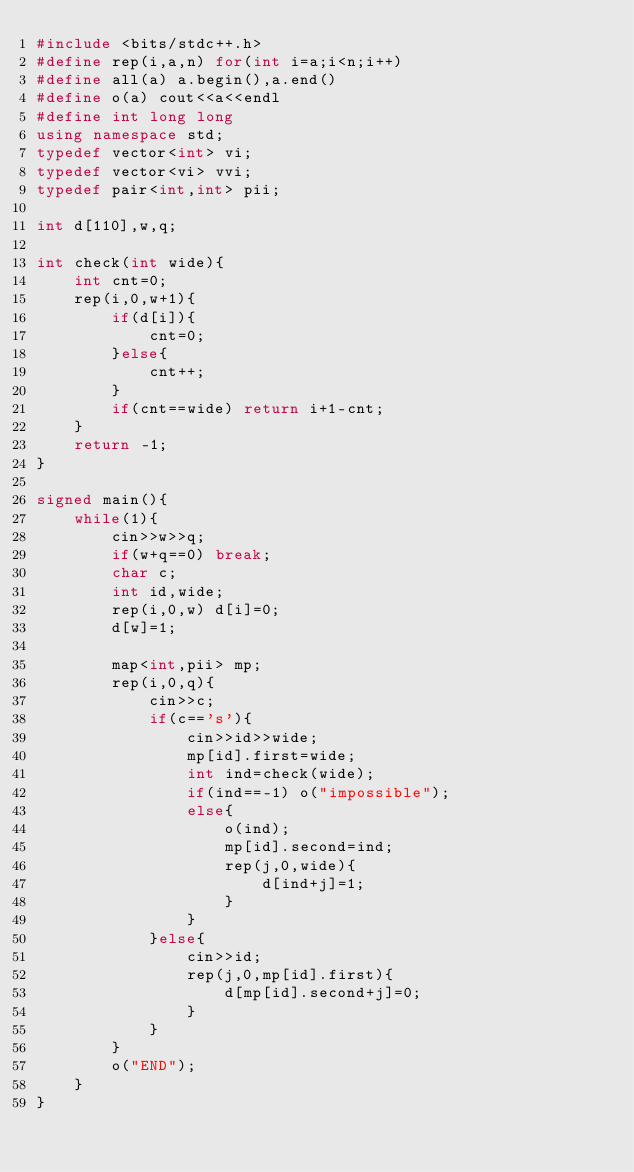<code> <loc_0><loc_0><loc_500><loc_500><_C++_>#include <bits/stdc++.h>
#define rep(i,a,n) for(int i=a;i<n;i++)
#define all(a) a.begin(),a.end()
#define o(a) cout<<a<<endl
#define int long long
using namespace std;
typedef vector<int> vi;
typedef vector<vi> vvi;
typedef pair<int,int> pii;

int d[110],w,q;

int check(int wide){
	int cnt=0;
	rep(i,0,w+1){
		if(d[i]){
			cnt=0;
		}else{
			cnt++;
		}
		if(cnt==wide) return i+1-cnt;
	}
	return -1;
}

signed main(){
	while(1){
		cin>>w>>q;
		if(w+q==0) break;
		char c;
		int id,wide;
		rep(i,0,w) d[i]=0;
		d[w]=1;

		map<int,pii> mp;
		rep(i,0,q){
			cin>>c;
			if(c=='s'){
				cin>>id>>wide;
				mp[id].first=wide;
				int ind=check(wide);
				if(ind==-1) o("impossible");
				else{
					o(ind);
					mp[id].second=ind;
					rep(j,0,wide){
						d[ind+j]=1;
					}
				}
			}else{
				cin>>id;
				rep(j,0,mp[id].first){
					d[mp[id].second+j]=0;
				}
			}
		}
		o("END");
	}
}</code> 